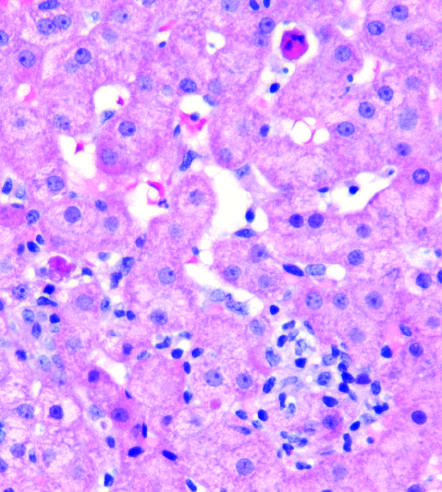what does this biopsy from a patient with lobular hepatitis due to chronic hepatitis c show?
Answer the question using a single word or phrase. Scattered apoptotic hepatocytes and a patchy inflammatory infiltrate 